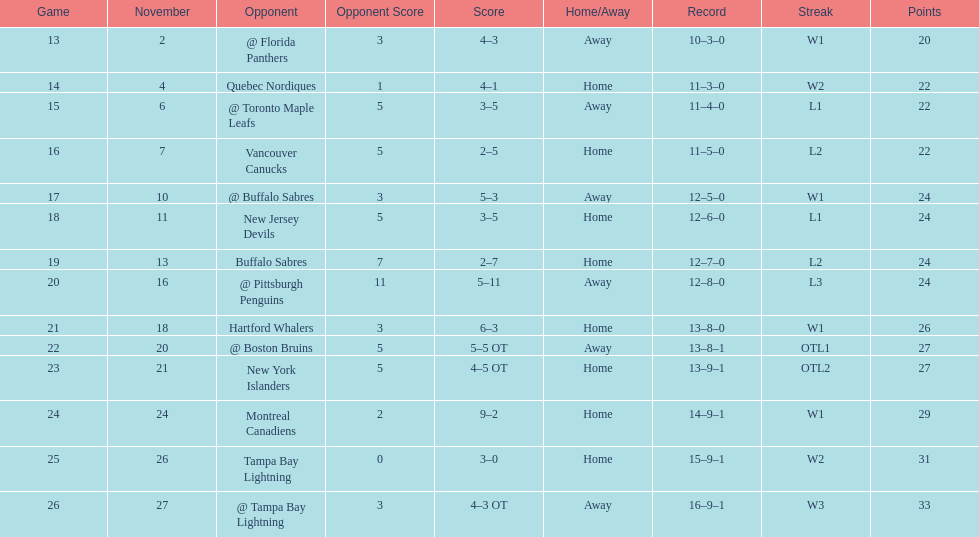What was the total penalty minutes that dave brown had on the 1993-1994 flyers? 137. 